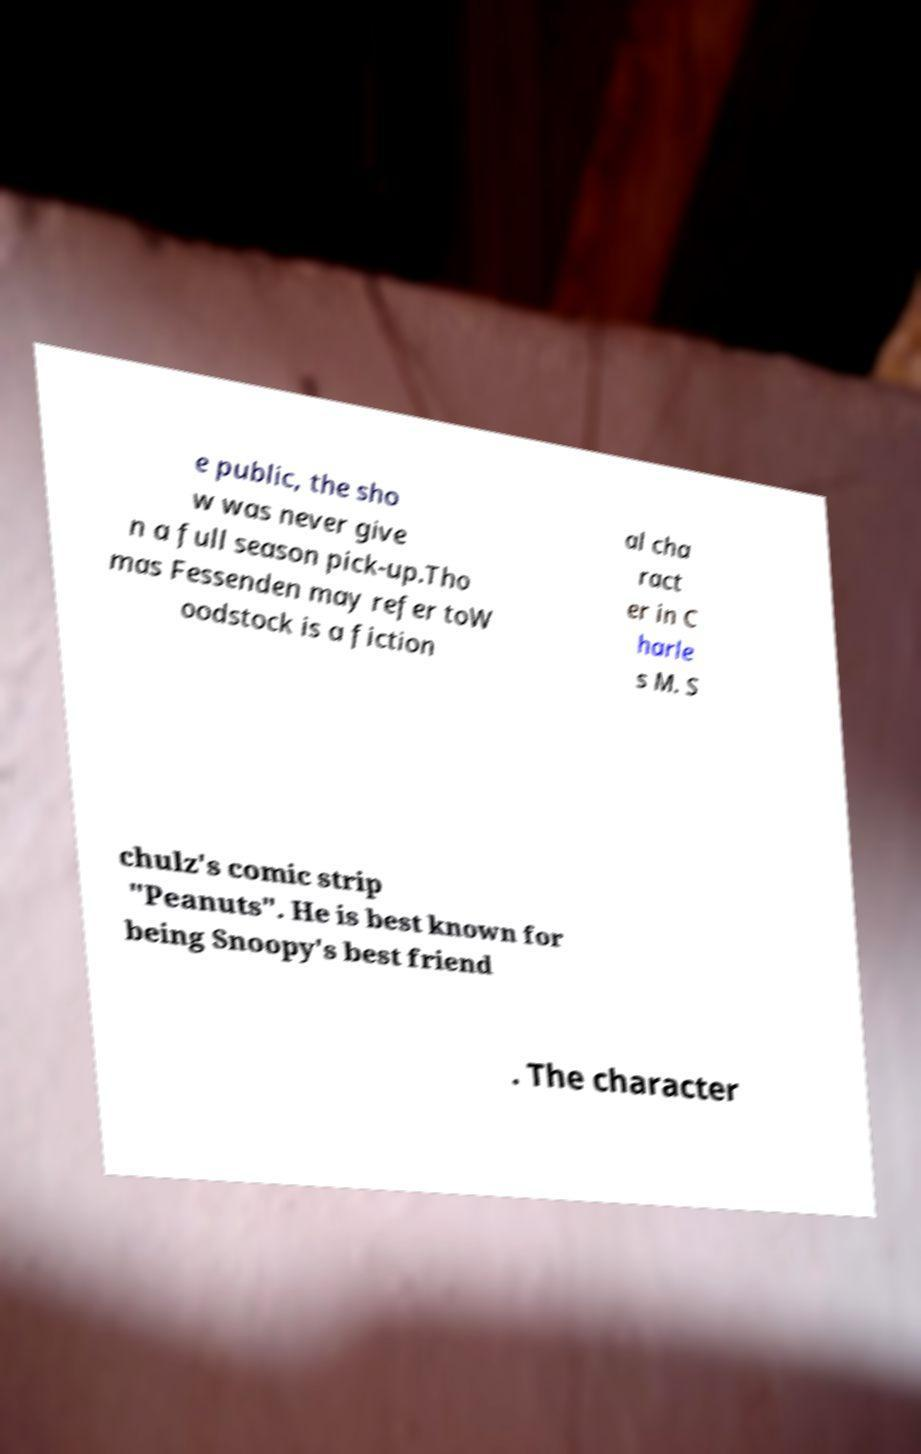Can you read and provide the text displayed in the image?This photo seems to have some interesting text. Can you extract and type it out for me? e public, the sho w was never give n a full season pick-up.Tho mas Fessenden may refer toW oodstock is a fiction al cha ract er in C harle s M. S chulz's comic strip "Peanuts". He is best known for being Snoopy's best friend . The character 